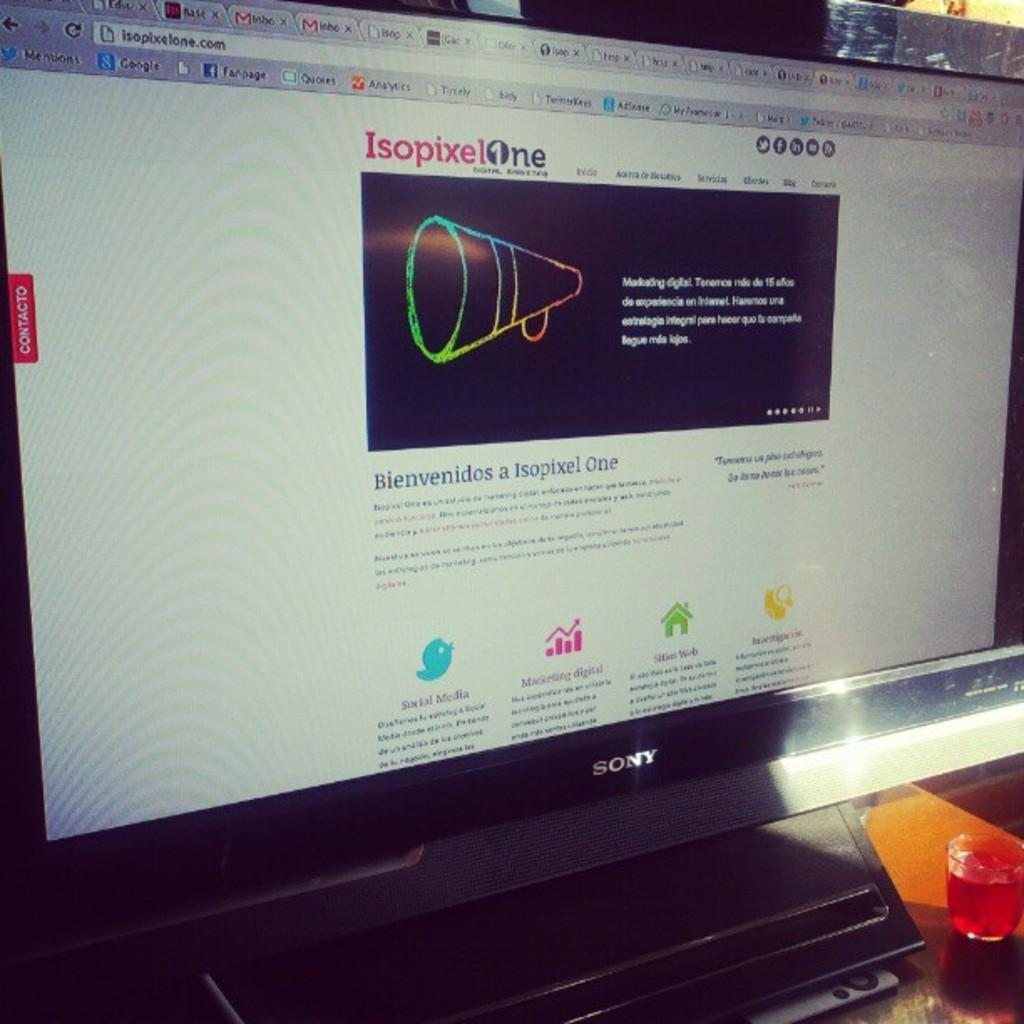Provide a one-sentence caption for the provided image. Isopixelone's website is shown on the computer screen in a foreign language. 